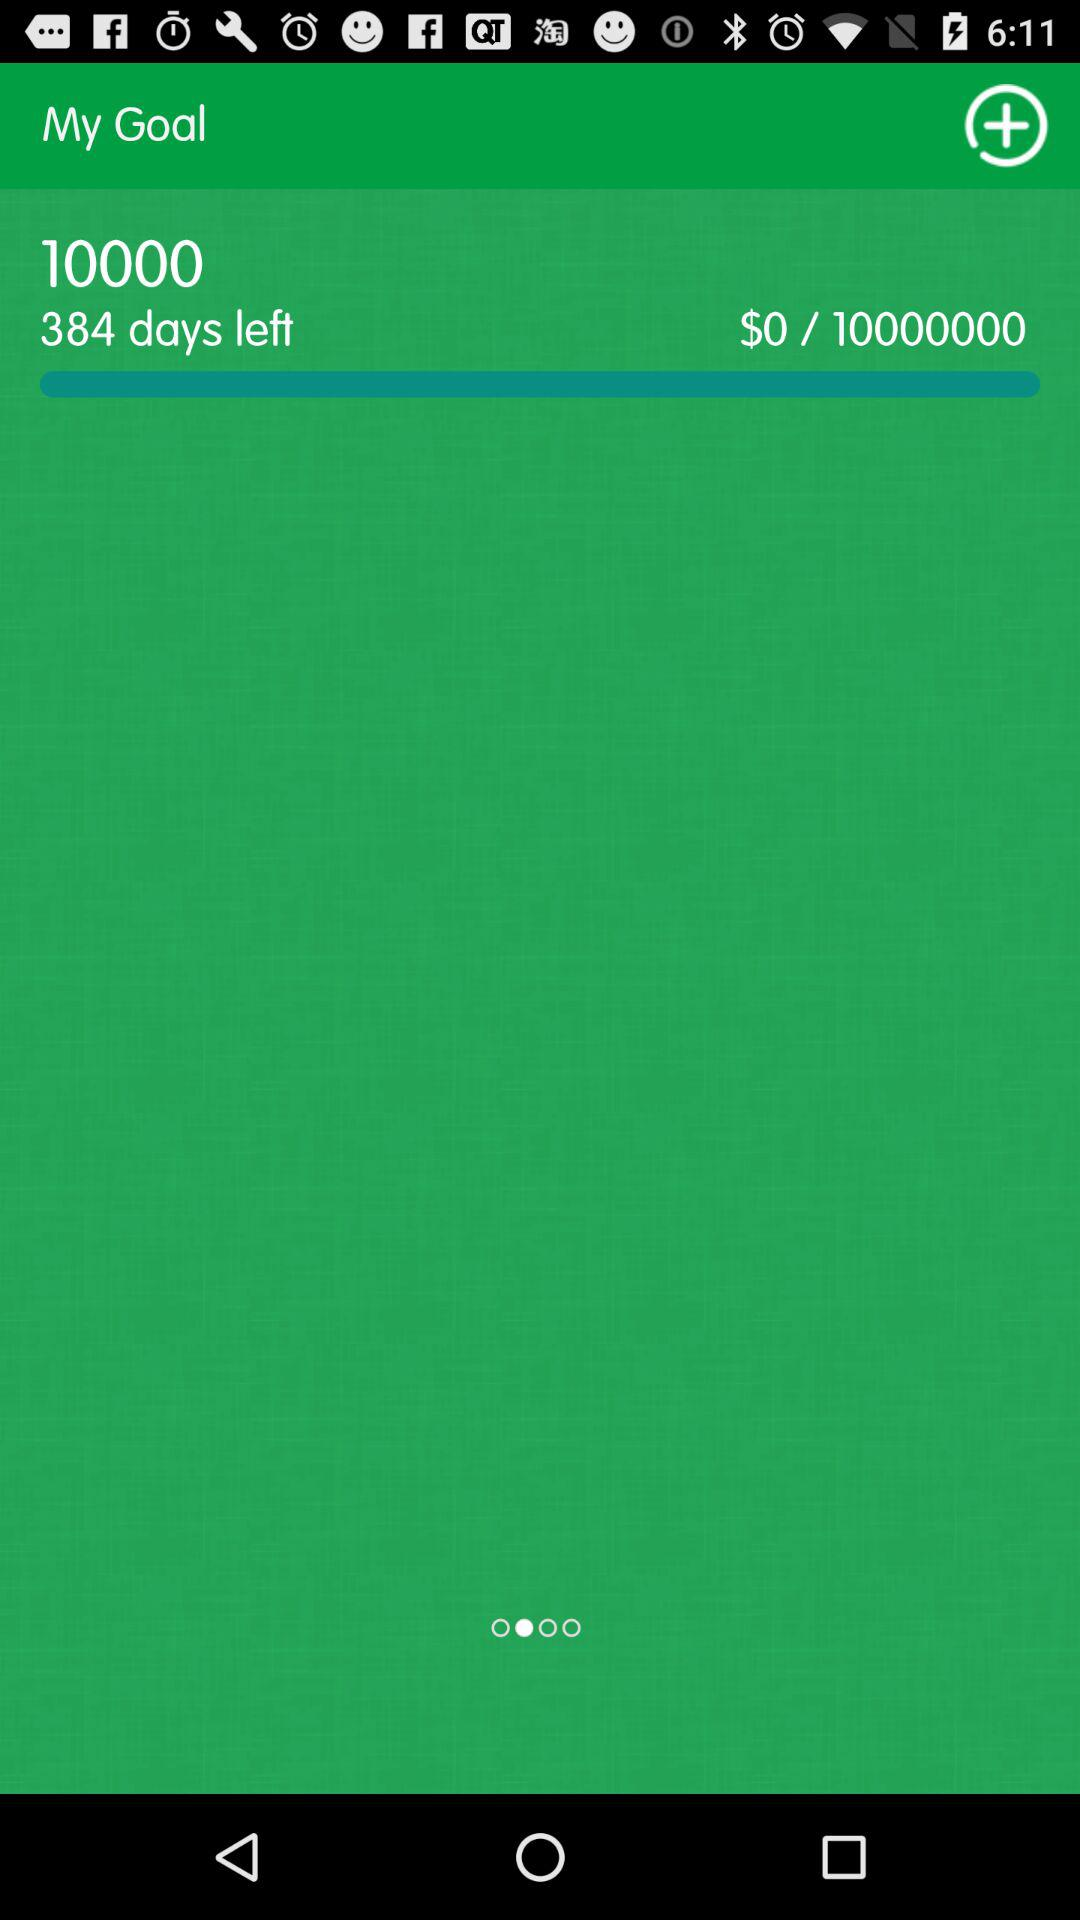How many days are left? There are 384 days left. 